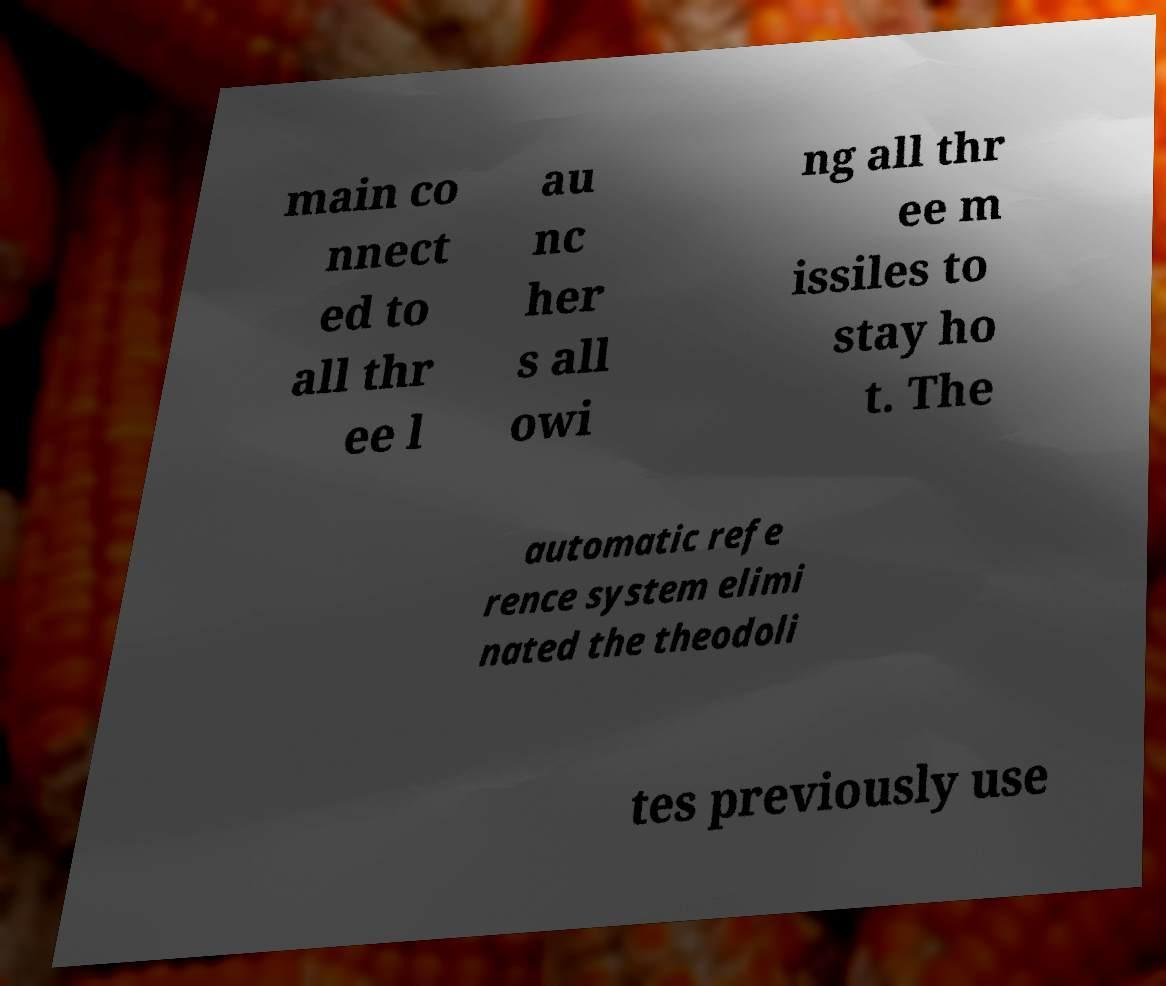I need the written content from this picture converted into text. Can you do that? main co nnect ed to all thr ee l au nc her s all owi ng all thr ee m issiles to stay ho t. The automatic refe rence system elimi nated the theodoli tes previously use 